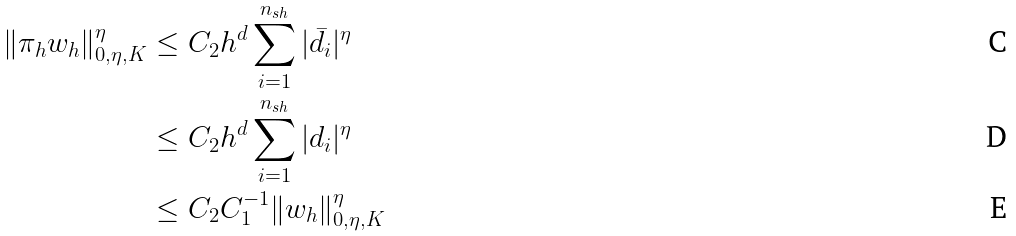Convert formula to latex. <formula><loc_0><loc_0><loc_500><loc_500>\| \pi _ { h } w _ { h } \| _ { 0 , \eta , K } ^ { \eta } & \leq C _ { 2 } h ^ { d } \sum _ { i = 1 } ^ { n _ { s h } } | \bar { d } _ { i } | ^ { \eta } \\ & \leq C _ { 2 } h ^ { d } \sum _ { i = 1 } ^ { n _ { s h } } | d _ { i } | ^ { \eta } \\ & \leq C _ { 2 } C _ { 1 } ^ { - 1 } \| w _ { h } \| _ { 0 , \eta , K } ^ { \eta }</formula> 